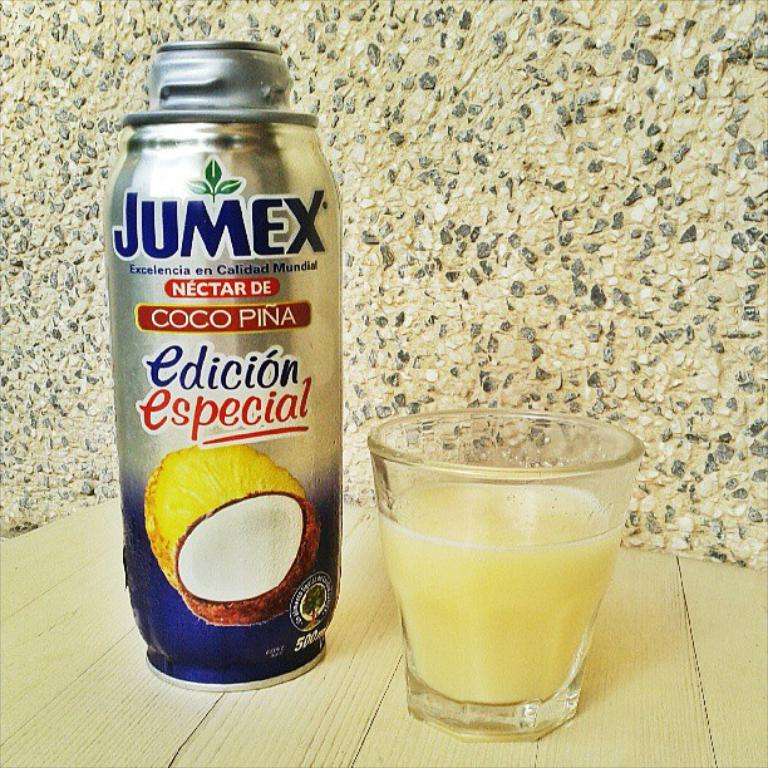What object is located on the left side of the image? There is a tin on the left side of the image. What can be seen on the right side of the image? There is a glass of liquid on the right side of the image. What is visible in the background of the image? There is a wall visible in the background of the image. Can you hear the goose laughing in the image? There is no goose or laughter present in the image. What type of horn is visible on the wall in the image? There is no horn visible on the wall in the image. 